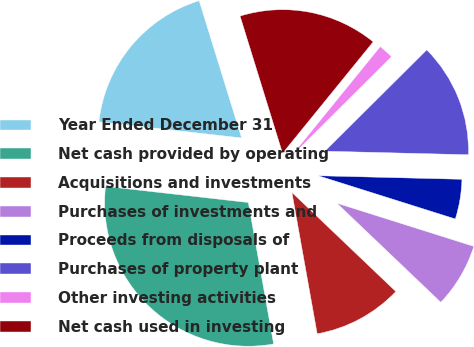Convert chart to OTSL. <chart><loc_0><loc_0><loc_500><loc_500><pie_chart><fcel>Year Ended December 31<fcel>Net cash provided by operating<fcel>Acquisitions and investments<fcel>Purchases of investments and<fcel>Proceeds from disposals of<fcel>Purchases of property plant<fcel>Other investing activities<fcel>Net cash used in investing<nl><fcel>18.43%<fcel>29.61%<fcel>10.06%<fcel>7.26%<fcel>4.47%<fcel>12.85%<fcel>1.68%<fcel>15.64%<nl></chart> 